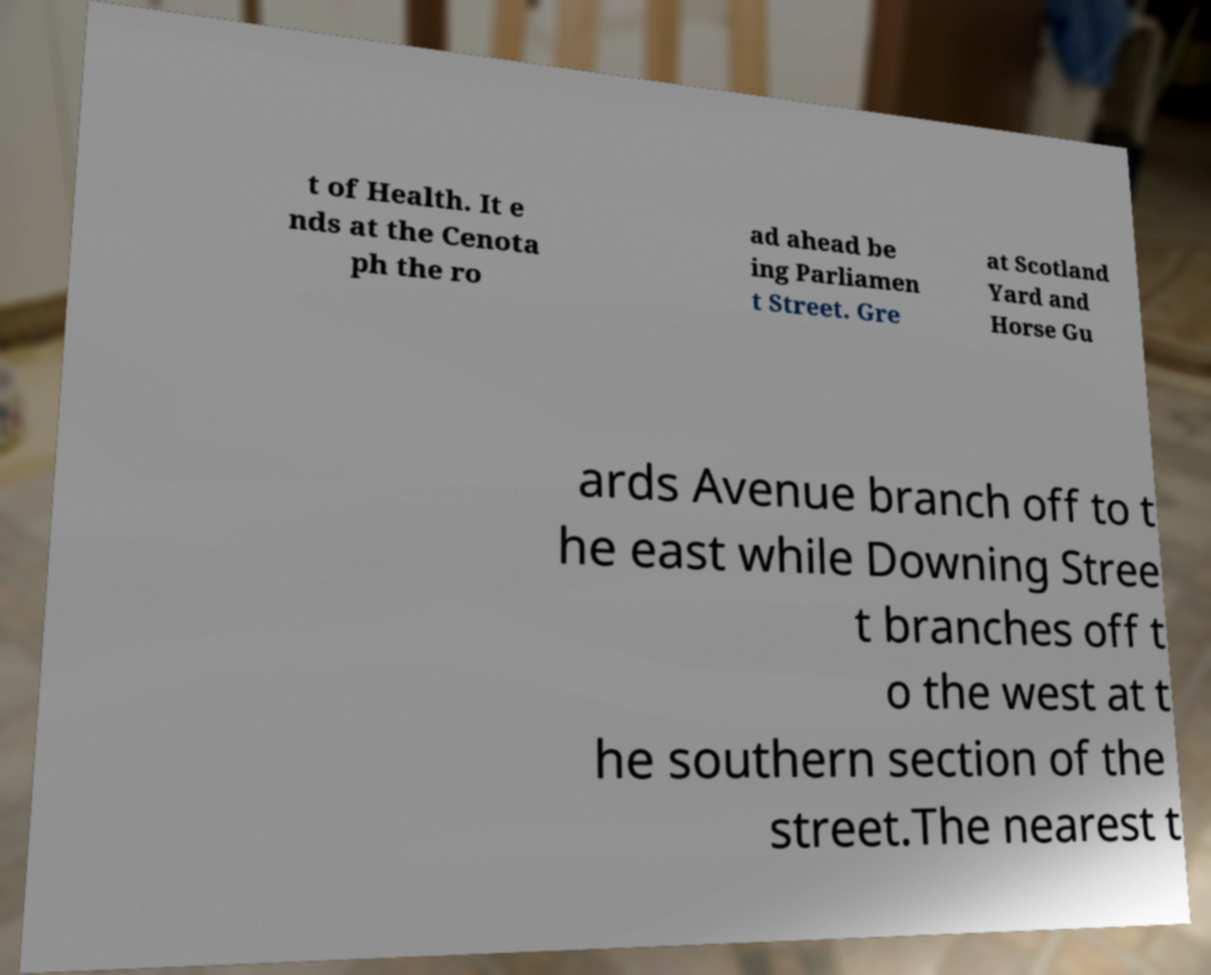Can you read and provide the text displayed in the image?This photo seems to have some interesting text. Can you extract and type it out for me? t of Health. It e nds at the Cenota ph the ro ad ahead be ing Parliamen t Street. Gre at Scotland Yard and Horse Gu ards Avenue branch off to t he east while Downing Stree t branches off t o the west at t he southern section of the street.The nearest t 